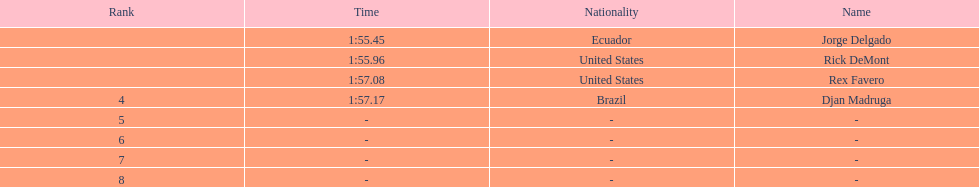What come after rex f. Djan Madruga. 